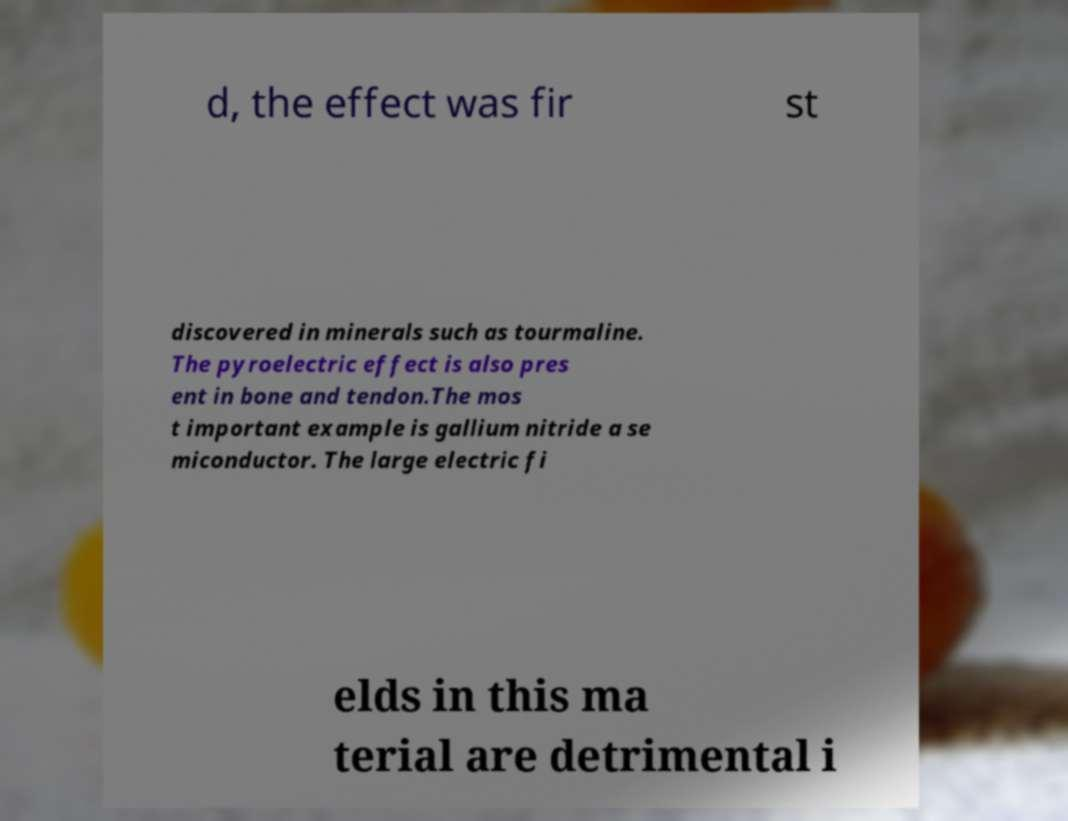Please identify and transcribe the text found in this image. d, the effect was fir st discovered in minerals such as tourmaline. The pyroelectric effect is also pres ent in bone and tendon.The mos t important example is gallium nitride a se miconductor. The large electric fi elds in this ma terial are detrimental i 